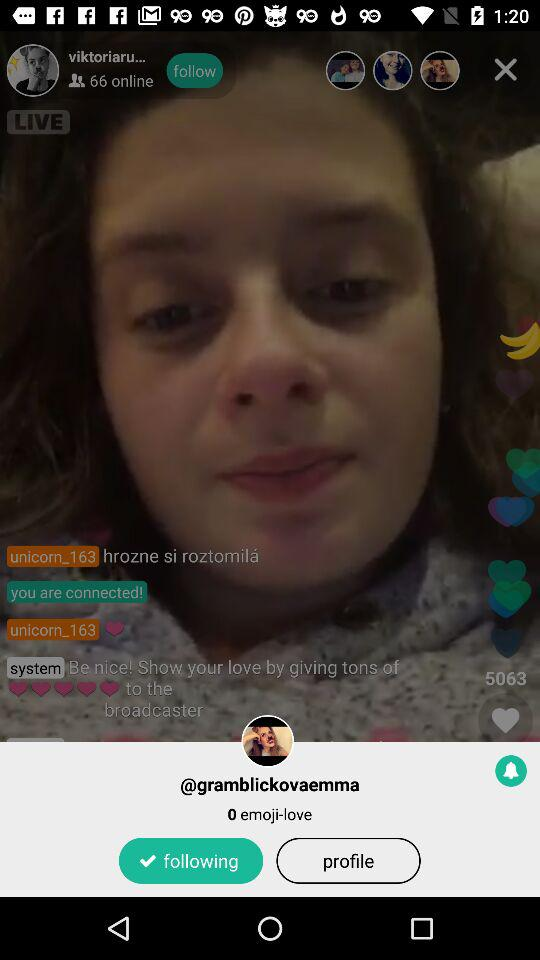How many people are online?
Answer the question using a single word or phrase. 66 